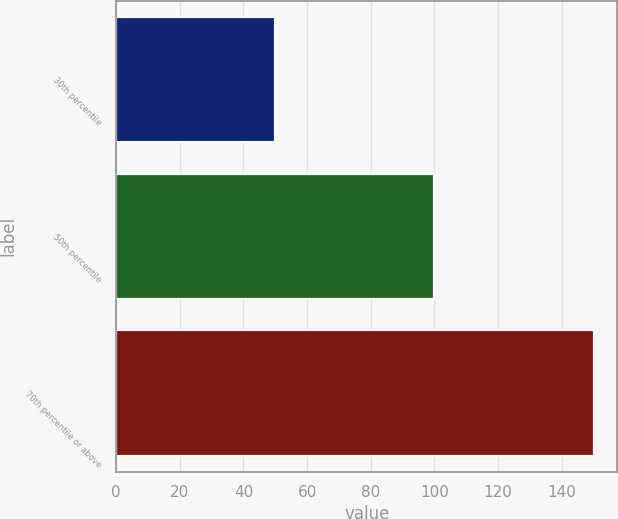<chart> <loc_0><loc_0><loc_500><loc_500><bar_chart><fcel>30th percentile<fcel>50th percentile<fcel>70th percentile or above<nl><fcel>50<fcel>100<fcel>150<nl></chart> 